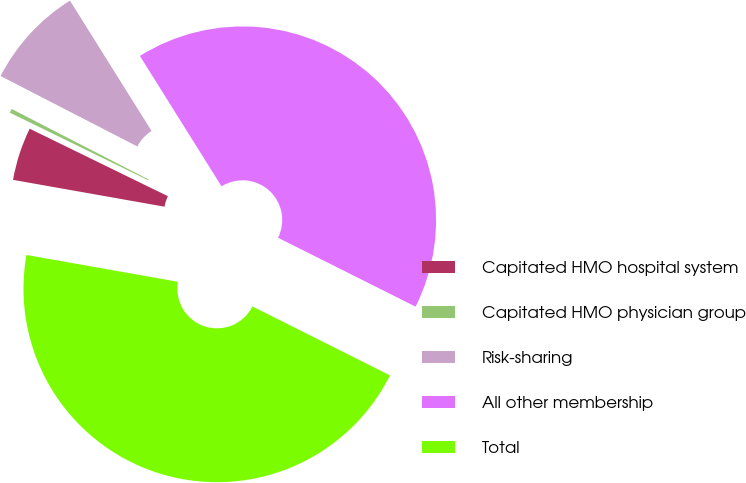<chart> <loc_0><loc_0><loc_500><loc_500><pie_chart><fcel>Capitated HMO hospital system<fcel>Capitated HMO physician group<fcel>Risk-sharing<fcel>All other membership<fcel>Total<nl><fcel>4.44%<fcel>0.34%<fcel>8.53%<fcel>41.3%<fcel>45.4%<nl></chart> 